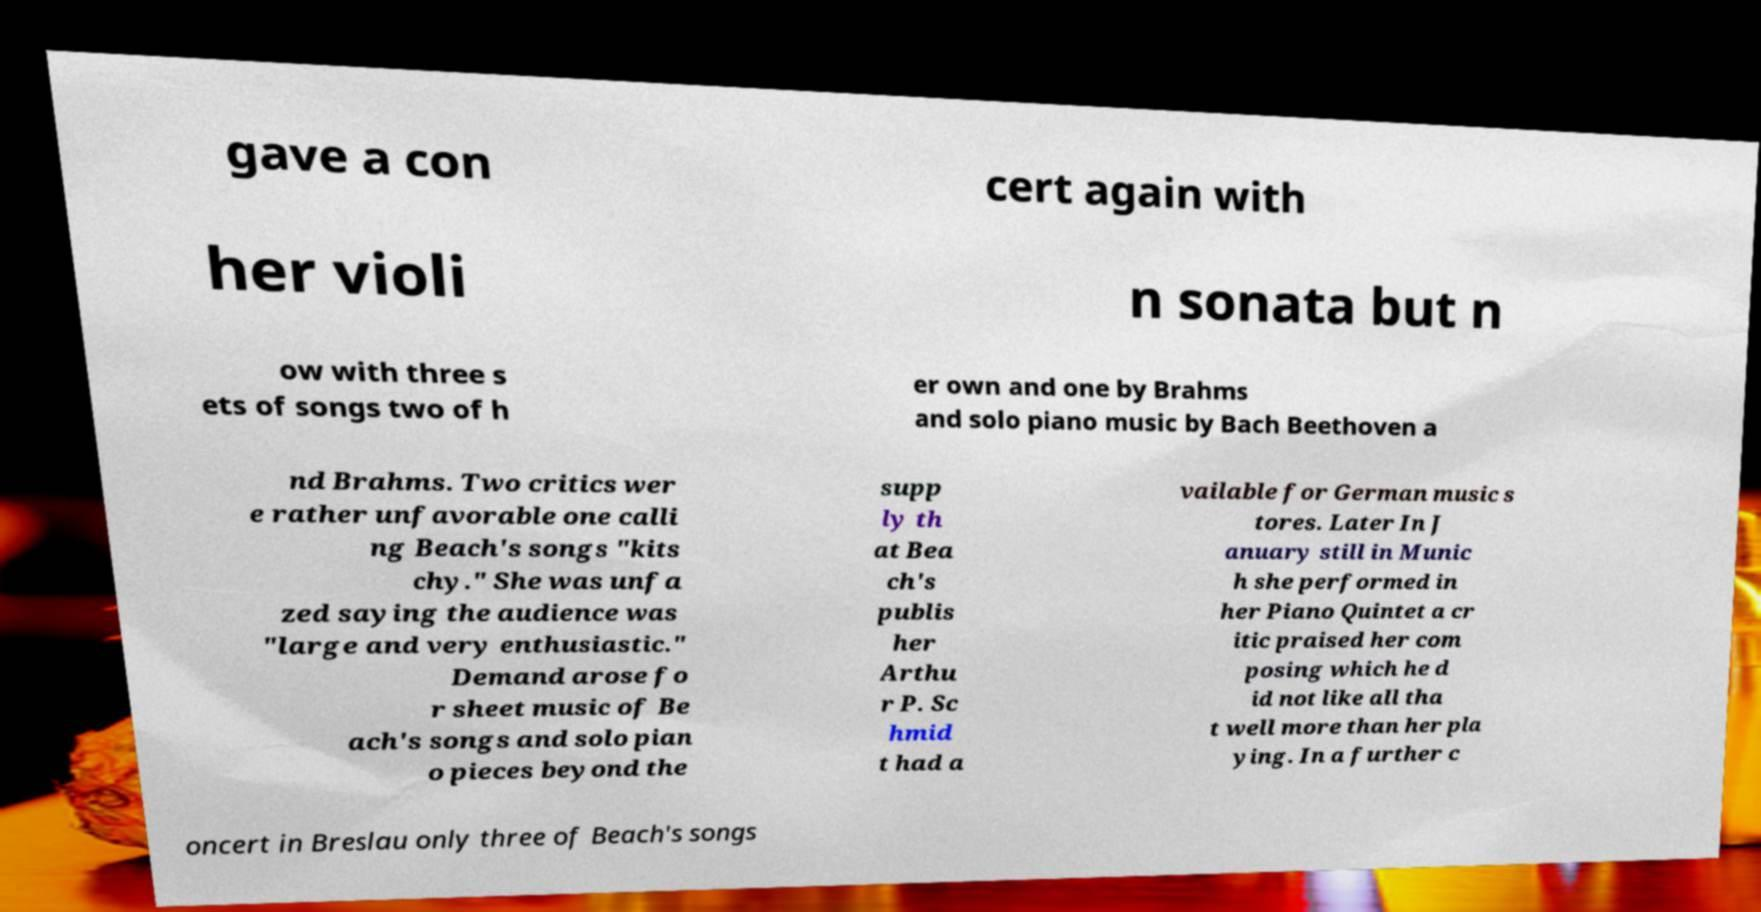Could you extract and type out the text from this image? gave a con cert again with her violi n sonata but n ow with three s ets of songs two of h er own and one by Brahms and solo piano music by Bach Beethoven a nd Brahms. Two critics wer e rather unfavorable one calli ng Beach's songs "kits chy." She was unfa zed saying the audience was "large and very enthusiastic." Demand arose fo r sheet music of Be ach's songs and solo pian o pieces beyond the supp ly th at Bea ch's publis her Arthu r P. Sc hmid t had a vailable for German music s tores. Later In J anuary still in Munic h she performed in her Piano Quintet a cr itic praised her com posing which he d id not like all tha t well more than her pla ying. In a further c oncert in Breslau only three of Beach's songs 